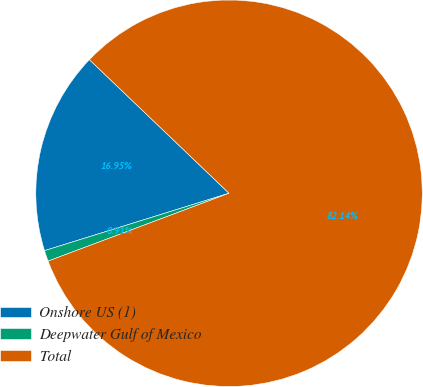Convert chart. <chart><loc_0><loc_0><loc_500><loc_500><pie_chart><fcel>Onshore US (1)<fcel>Deepwater Gulf of Mexico<fcel>Total<nl><fcel>16.95%<fcel>0.91%<fcel>82.14%<nl></chart> 